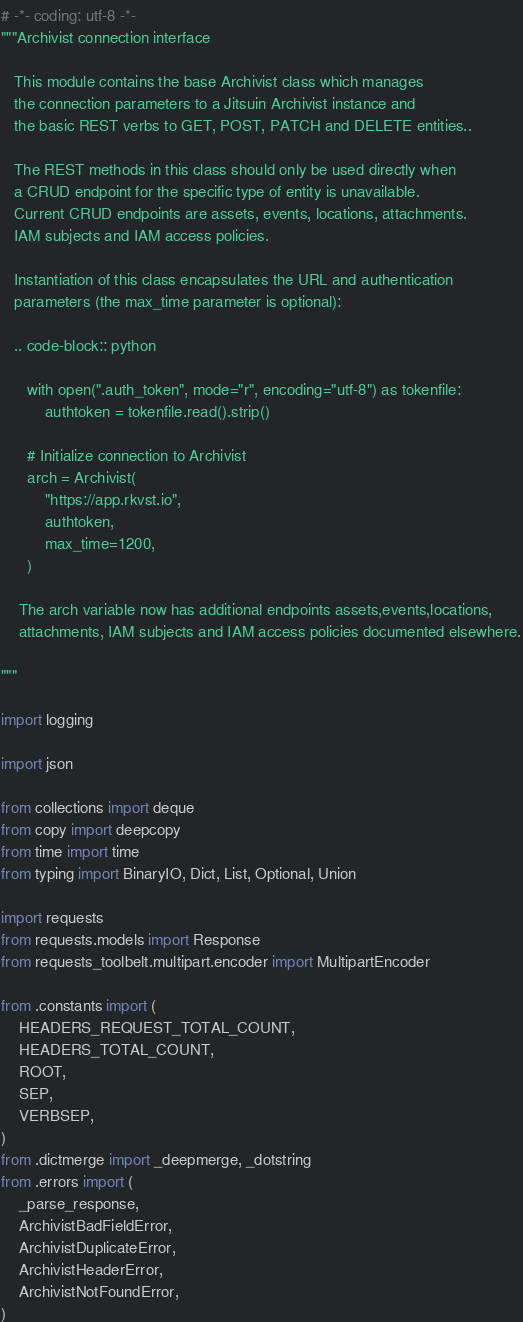<code> <loc_0><loc_0><loc_500><loc_500><_Python_># -*- coding: utf-8 -*-
"""Archivist connection interface

   This module contains the base Archivist class which manages
   the connection parameters to a Jitsuin Archivist instance and
   the basic REST verbs to GET, POST, PATCH and DELETE entities..

   The REST methods in this class should only be used directly when
   a CRUD endpoint for the specific type of entity is unavailable.
   Current CRUD endpoints are assets, events, locations, attachments.
   IAM subjects and IAM access policies.

   Instantiation of this class encapsulates the URL and authentication
   parameters (the max_time parameter is optional):

   .. code-block:: python

      with open(".auth_token", mode="r", encoding="utf-8") as tokenfile:
          authtoken = tokenfile.read().strip()

      # Initialize connection to Archivist
      arch = Archivist(
          "https://app.rkvst.io",
          authtoken,
          max_time=1200,
      )

    The arch variable now has additional endpoints assets,events,locations,
    attachments, IAM subjects and IAM access policies documented elsewhere.

"""

import logging

import json

from collections import deque
from copy import deepcopy
from time import time
from typing import BinaryIO, Dict, List, Optional, Union

import requests
from requests.models import Response
from requests_toolbelt.multipart.encoder import MultipartEncoder

from .constants import (
    HEADERS_REQUEST_TOTAL_COUNT,
    HEADERS_TOTAL_COUNT,
    ROOT,
    SEP,
    VERBSEP,
)
from .dictmerge import _deepmerge, _dotstring
from .errors import (
    _parse_response,
    ArchivistBadFieldError,
    ArchivistDuplicateError,
    ArchivistHeaderError,
    ArchivistNotFoundError,
)</code> 